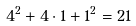<formula> <loc_0><loc_0><loc_500><loc_500>4 ^ { 2 } + 4 \cdot 1 + 1 ^ { 2 } = 2 1</formula> 